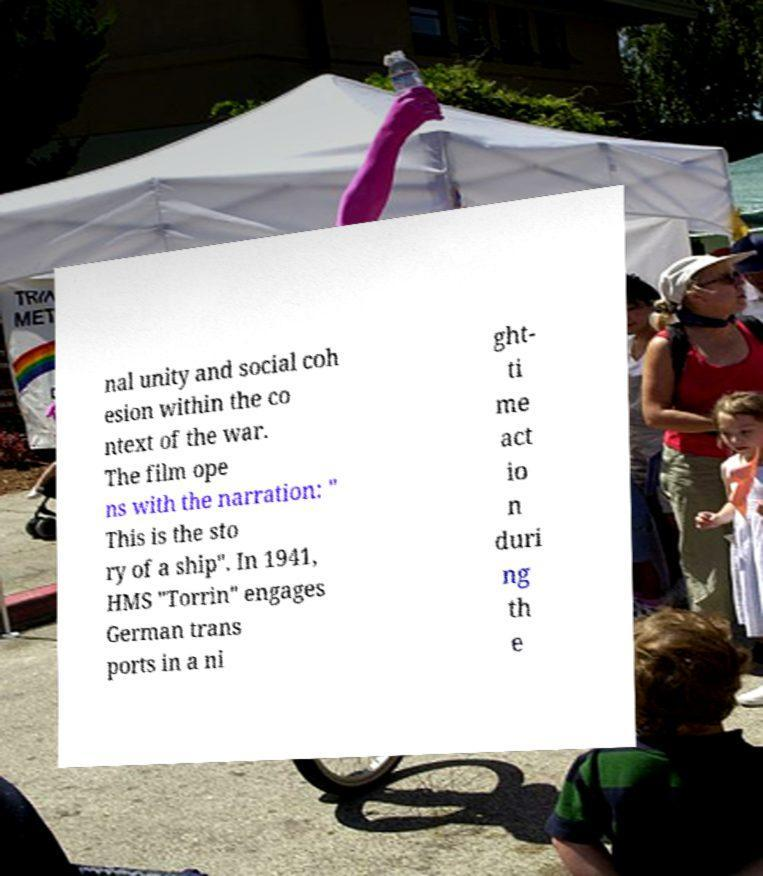Could you assist in decoding the text presented in this image and type it out clearly? nal unity and social coh esion within the co ntext of the war. The film ope ns with the narration: " This is the sto ry of a ship". In 1941, HMS "Torrin" engages German trans ports in a ni ght- ti me act io n duri ng th e 